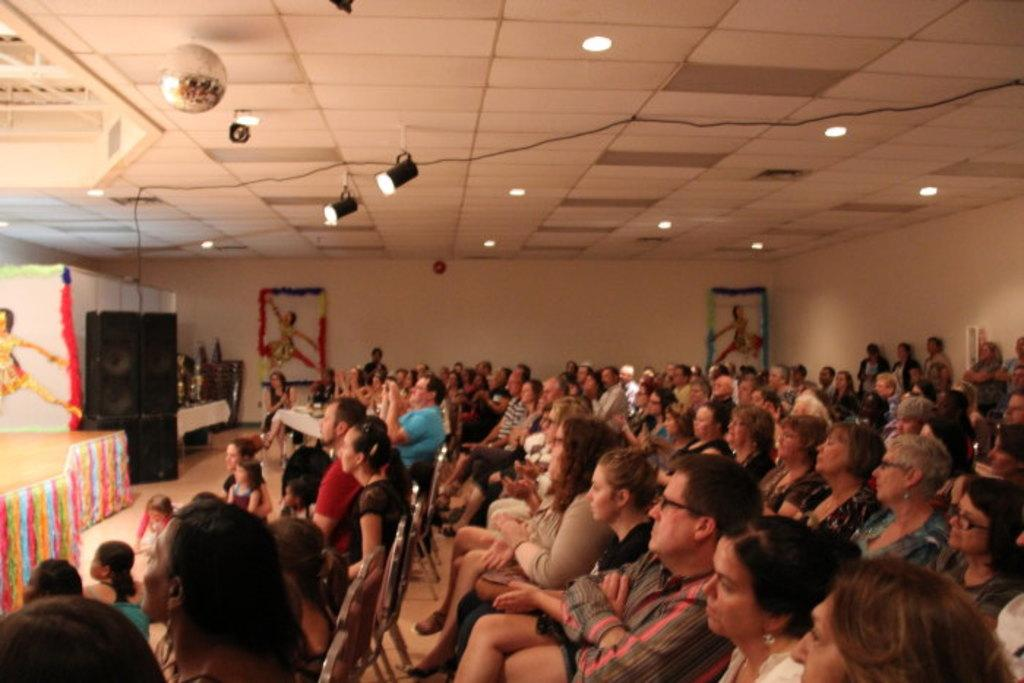How many people are present in the room in the image? There are many people sitting in the room. What can be seen on the left side of the room? There is a stage on the left side of the room. What is located at the back of the room? There are photo frames at the back of the room. What is present at the top of the room? There are lights at the top of the room. What type of swing can be seen in the image? There is no swing present in the image. How many children are visible in the image? The image does not specify the age of the people present, so it is not possible to determine if there are any children. 